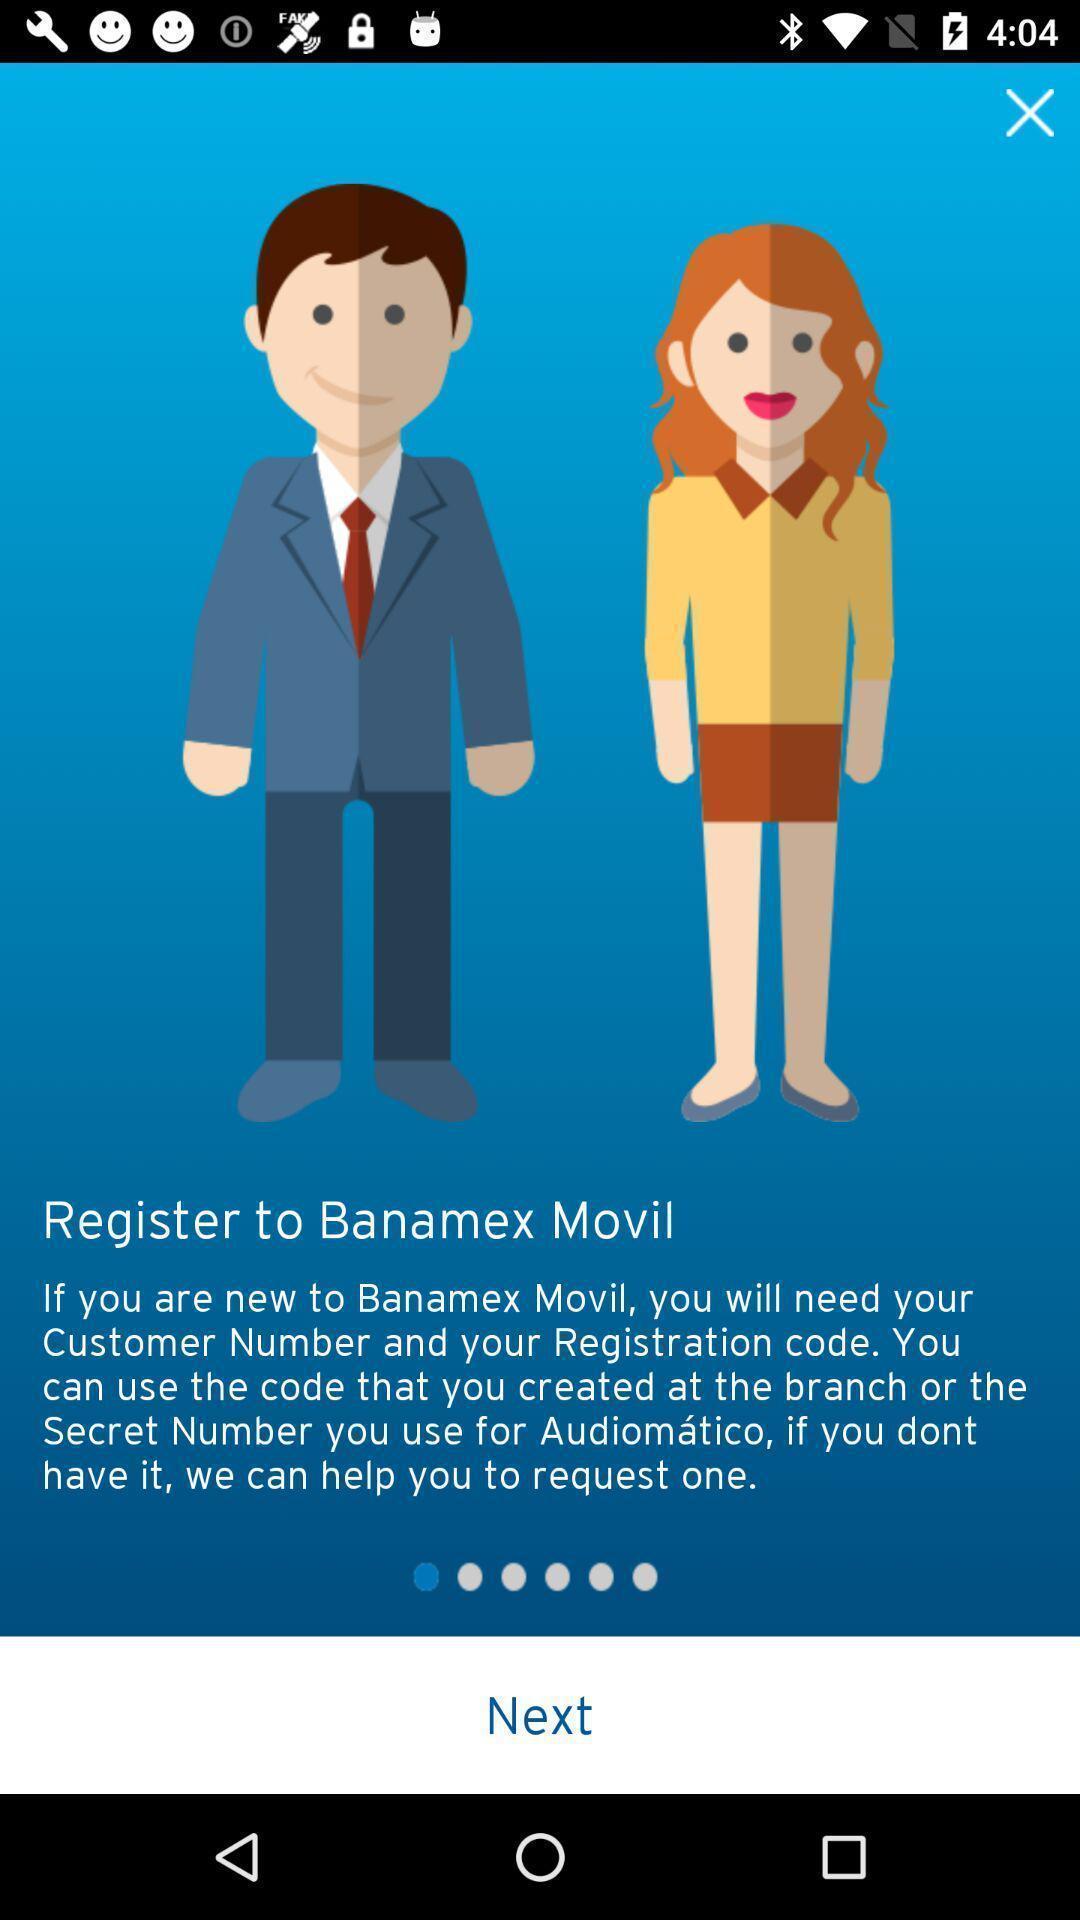Summarize the main components in this picture. Welcome page. 